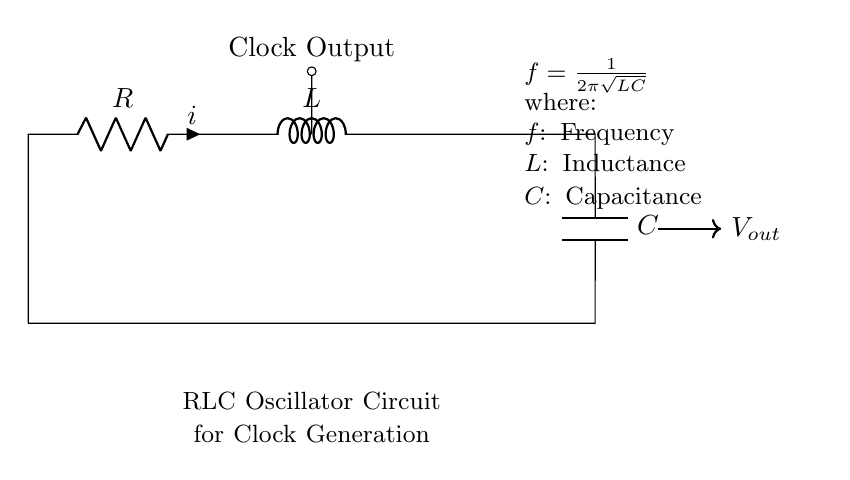What are the components in the circuit? The circuit contains a resistor, inductor, and capacitor, as indicated by the labels R, L, and C respectively.
Answer: Resistor, Inductor, Capacitor What type of output does this circuit generate? The circuit produces a clock signal output, which is indicated by the label "Clock Output" above the output node.
Answer: Clock signal What is the formula given for the frequency? The formula provided is: f = 1/(2π√(LC)), which relates the frequency to the inductance and capacitance values.
Answer: f = 1/(2π√(LC)) How many elements are in the RLC circuit? There are three elements present: one resistor, one inductor, and one capacitor, as shown in the diagram.
Answer: Three What does L stand for in the circuit? In the context of this circuit, L represents the inductance, which is a property of the inductor.
Answer: Inductance Why is the clock output important in digital systems? The clock output is crucial as it synchronizes operations within digital systems, ensuring that components work in harmony.
Answer: Synchronization What is the meaning of the current (i) in the circuit? The current (i) indicates the flow of charge through the resistor and is an important parameter for understanding the circuit's behavior.
Answer: Flow of charge 